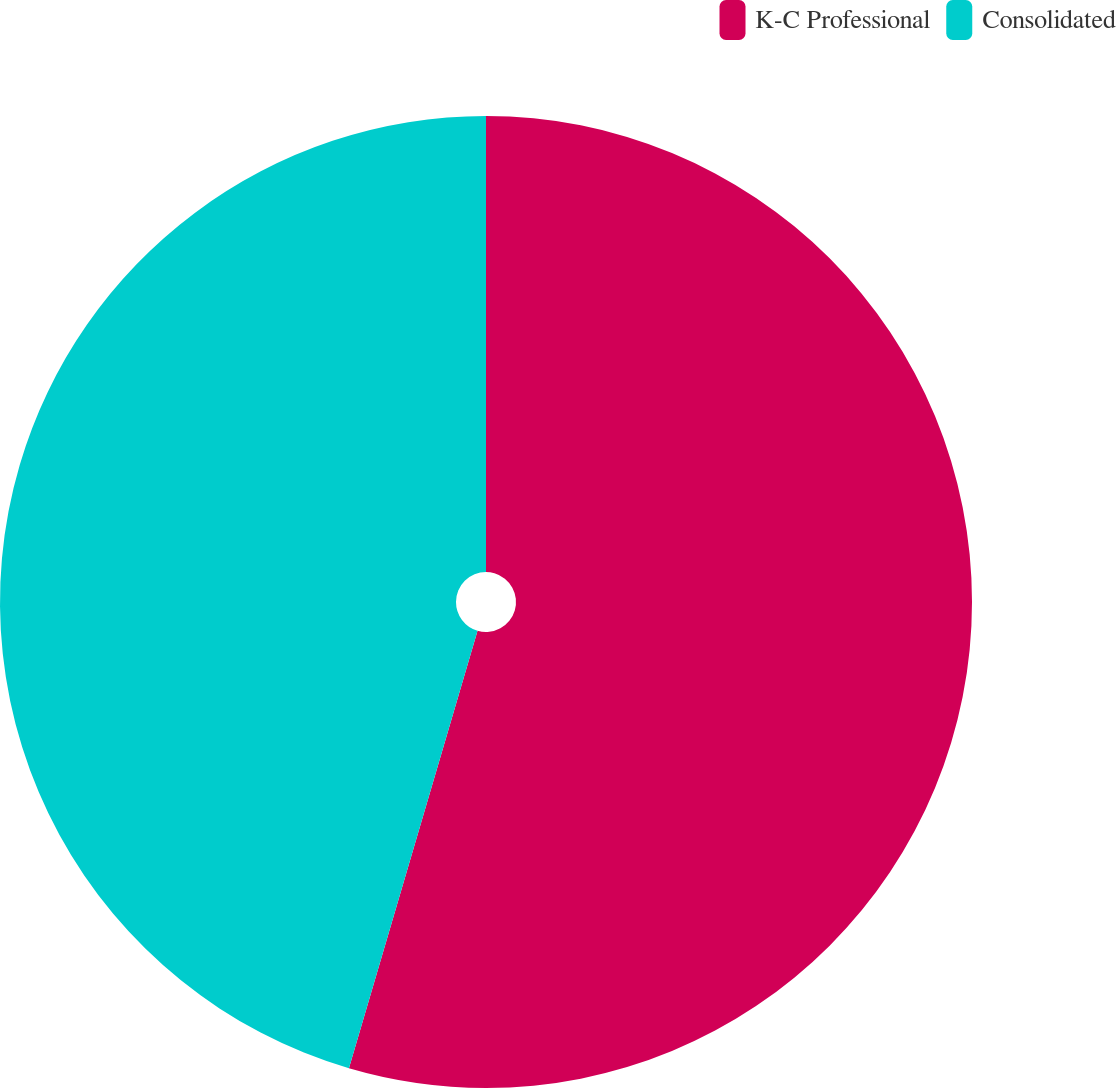Convert chart to OTSL. <chart><loc_0><loc_0><loc_500><loc_500><pie_chart><fcel>K-C Professional<fcel>Consolidated<nl><fcel>54.55%<fcel>45.45%<nl></chart> 